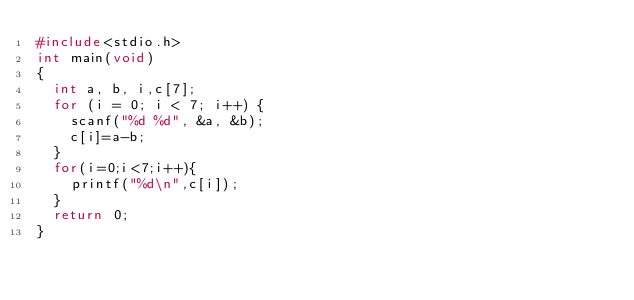Convert code to text. <code><loc_0><loc_0><loc_500><loc_500><_C_>#include<stdio.h>
int main(void)
{
	int a, b, i,c[7];
	for (i = 0; i < 7; i++) {
		scanf("%d %d", &a, &b);
		c[i]=a-b;
	}
	for(i=0;i<7;i++){
		printf("%d\n",c[i]);
	}
	return 0;
}</code> 